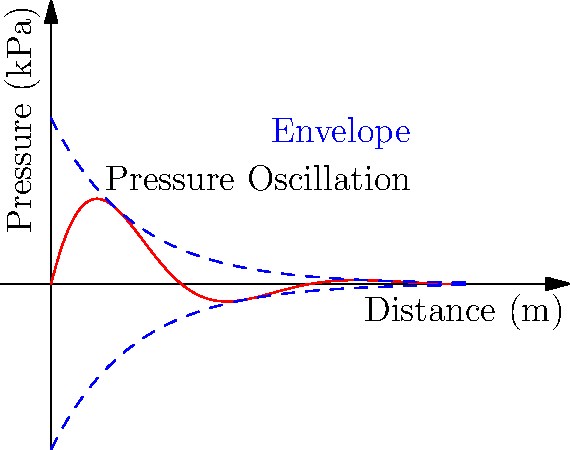In a fire suppression sprinkler system, water hammer can cause pressure oscillations that affect the fluid dynamics of water droplets. The graph shows the pressure oscillation in a pipe after a sudden valve closure. If the initial pressure amplitude is 4 kPa and the oscillation decays exponentially with a time constant of 2 seconds, what is the pressure amplitude after 4 seconds? To solve this problem, we need to follow these steps:

1. Identify the equation for exponential decay:
   $P(t) = P_0 e^{-t/\tau}$
   Where:
   $P(t)$ is the pressure at time $t$
   $P_0$ is the initial pressure amplitude
   $\tau$ is the time constant
   $t$ is the time

2. Given information:
   $P_0 = 4$ kPa
   $\tau = 2$ seconds
   $t = 4$ seconds

3. Substitute the values into the equation:
   $P(4) = 4 e^{-4/2}$

4. Simplify:
   $P(4) = 4 e^{-2}$

5. Calculate the result:
   $P(4) = 4 * (0.1353) = 0.5412$ kPa

Therefore, the pressure amplitude after 4 seconds is approximately 0.54 kPa.
Answer: 0.54 kPa 